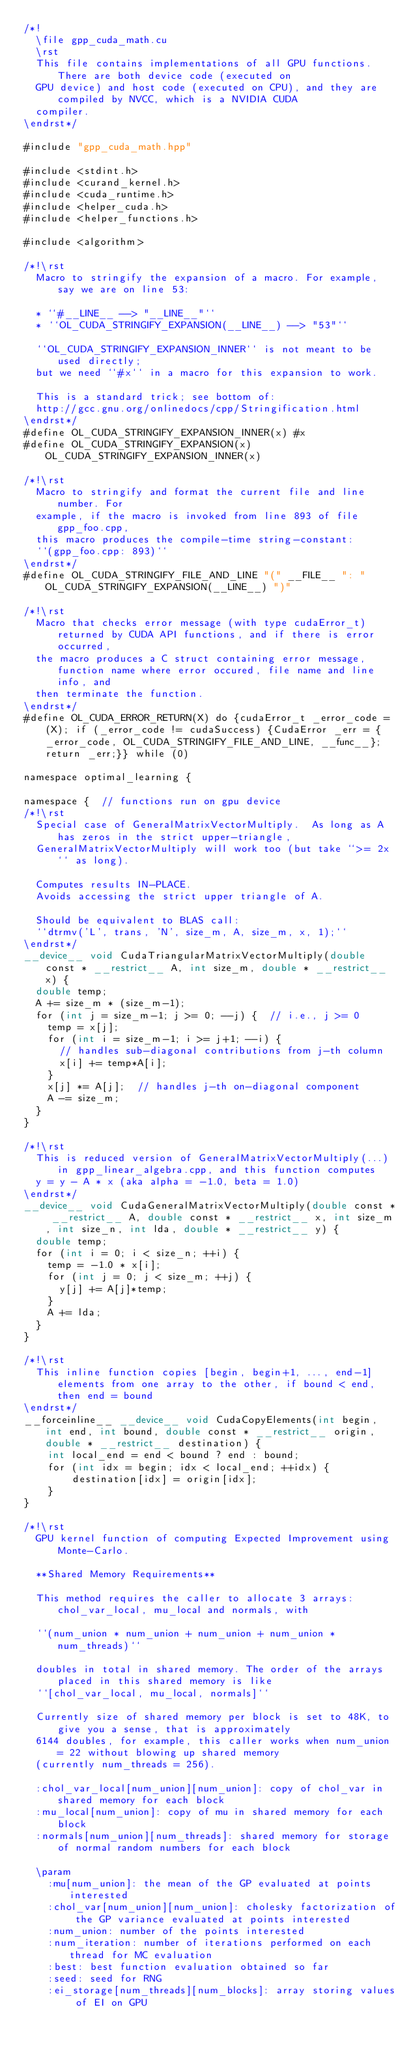Convert code to text. <code><loc_0><loc_0><loc_500><loc_500><_Cuda_>/*!
  \file gpp_cuda_math.cu
  \rst
  This file contains implementations of all GPU functions. There are both device code (executed on
  GPU device) and host code (executed on CPU), and they are compiled by NVCC, which is a NVIDIA CUDA
  compiler.
\endrst*/

#include "gpp_cuda_math.hpp"

#include <stdint.h>
#include <curand_kernel.h>
#include <cuda_runtime.h>
#include <helper_cuda.h>
#include <helper_functions.h>

#include <algorithm>

/*!\rst
  Macro to stringify the expansion of a macro. For example, say we are on line 53:

  * ``#__LINE__ --> "__LINE__"``
  * ``OL_CUDA_STRINGIFY_EXPANSION(__LINE__) --> "53"``

  ``OL_CUDA_STRINGIFY_EXPANSION_INNER`` is not meant to be used directly;
  but we need ``#x`` in a macro for this expansion to work.

  This is a standard trick; see bottom of:
  http://gcc.gnu.org/onlinedocs/cpp/Stringification.html
\endrst*/
#define OL_CUDA_STRINGIFY_EXPANSION_INNER(x) #x
#define OL_CUDA_STRINGIFY_EXPANSION(x) OL_CUDA_STRINGIFY_EXPANSION_INNER(x)

/*!\rst
  Macro to stringify and format the current file and line number. For
  example, if the macro is invoked from line 893 of file gpp_foo.cpp,
  this macro produces the compile-time string-constant:
  ``(gpp_foo.cpp: 893)``
\endrst*/
#define OL_CUDA_STRINGIFY_FILE_AND_LINE "(" __FILE__ ": " OL_CUDA_STRINGIFY_EXPANSION(__LINE__) ")"

/*!\rst
  Macro that checks error message (with type cudaError_t) returned by CUDA API functions, and if there is error occurred,
  the macro produces a C struct containing error message, function name where error occured, file name and line info, and 
  then terminate the function.
\endrst*/
#define OL_CUDA_ERROR_RETURN(X) do {cudaError_t _error_code = (X); if (_error_code != cudaSuccess) {CudaError _err = {_error_code, OL_CUDA_STRINGIFY_FILE_AND_LINE, __func__}; return _err;}} while (0)

namespace optimal_learning {

namespace {  // functions run on gpu device
/*!\rst
  Special case of GeneralMatrixVectorMultiply.  As long as A has zeros in the strict upper-triangle,
  GeneralMatrixVectorMultiply will work too (but take ``>= 2x`` as long).

  Computes results IN-PLACE.
  Avoids accessing the strict upper triangle of A.

  Should be equivalent to BLAS call:
  ``dtrmv('L', trans, 'N', size_m, A, size_m, x, 1);``
\endrst*/
__device__ void CudaTriangularMatrixVectorMultiply(double const * __restrict__ A, int size_m, double * __restrict__ x) {
  double temp;
  A += size_m * (size_m-1);
  for (int j = size_m-1; j >= 0; --j) {  // i.e., j >= 0
    temp = x[j];
    for (int i = size_m-1; i >= j+1; --i) {
      // handles sub-diagonal contributions from j-th column
      x[i] += temp*A[i];
    }
    x[j] *= A[j];  // handles j-th on-diagonal component
    A -= size_m;
  }
}

/*!\rst
  This is reduced version of GeneralMatrixVectorMultiply(...) in gpp_linear_algebra.cpp, and this function computes
  y = y - A * x (aka alpha = -1.0, beta = 1.0)
\endrst*/
__device__ void CudaGeneralMatrixVectorMultiply(double const * __restrict__ A, double const * __restrict__ x, int size_m, int size_n, int lda, double * __restrict__ y) {
  double temp;
  for (int i = 0; i < size_n; ++i) {
    temp = -1.0 * x[i];
    for (int j = 0; j < size_m; ++j) {
      y[j] += A[j]*temp;
    }
    A += lda;
  }
}

/*!\rst
  This inline function copies [begin, begin+1, ..., end-1] elements from one array to the other, if bound < end, then end = bound
\endrst*/
__forceinline__ __device__ void CudaCopyElements(int begin, int end, int bound, double const * __restrict__ origin, double * __restrict__ destination) {
    int local_end = end < bound ? end : bound;
    for (int idx = begin; idx < local_end; ++idx) {
        destination[idx] = origin[idx];
    }
}

/*!\rst
  GPU kernel function of computing Expected Improvement using Monte-Carlo.

  **Shared Memory Requirements**

  This method requires the caller to allocate 3 arrays: chol_var_local, mu_local and normals, with

  ``(num_union * num_union + num_union + num_union * num_threads)``

  doubles in total in shared memory. The order of the arrays placed in this shared memory is like
  ``[chol_var_local, mu_local, normals]``

  Currently size of shared memory per block is set to 48K, to give you a sense, that is approximately
  6144 doubles, for example, this caller works when num_union = 22 without blowing up shared memory
  (currently num_threads = 256).

  :chol_var_local[num_union][num_union]: copy of chol_var in shared memory for each block
  :mu_local[num_union]: copy of mu in shared memory for each block
  :normals[num_union][num_threads]: shared memory for storage of normal random numbers for each block

  \param
    :mu[num_union]: the mean of the GP evaluated at points interested
    :chol_var[num_union][num_union]: cholesky factorization of the GP variance evaluated at points interested
    :num_union: number of the points interested
    :num_iteration: number of iterations performed on each thread for MC evaluation
    :best: best function evaluation obtained so far
    :seed: seed for RNG
    :ei_storage[num_threads][num_blocks]: array storing values of EI on GPU</code> 